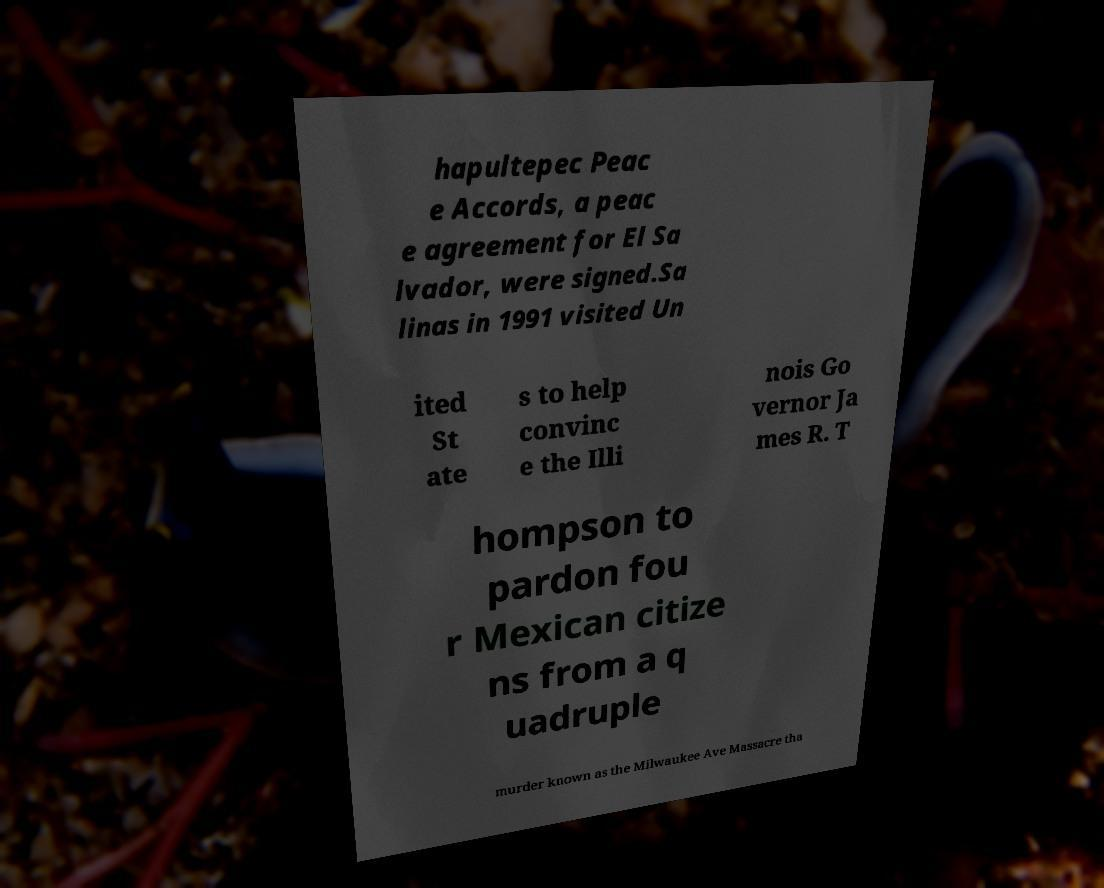Can you accurately transcribe the text from the provided image for me? hapultepec Peac e Accords, a peac e agreement for El Sa lvador, were signed.Sa linas in 1991 visited Un ited St ate s to help convinc e the Illi nois Go vernor Ja mes R. T hompson to pardon fou r Mexican citize ns from a q uadruple murder known as the Milwaukee Ave Massacre tha 